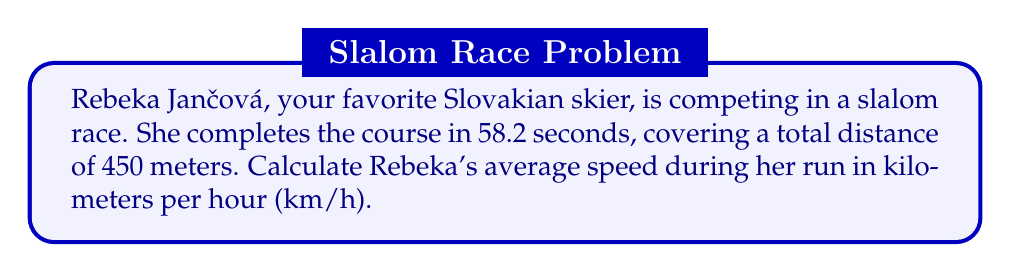Can you answer this question? To solve this problem, let's follow these steps:

1. Identify the given information:
   - Time taken: $t = 58.2$ seconds
   - Distance covered: $d = 450$ meters

2. Recall the formula for average speed:
   $$ \text{Average Speed} = \frac{\text{Total Distance}}{\text{Total Time}} $$

3. Calculate the average speed in meters per second:
   $$ \text{Average Speed} = \frac{450 \text{ m}}{58.2 \text{ s}} = 7.73 \text{ m/s} $$

4. Convert the speed from m/s to km/h:
   - There are 1000 meters in a kilometer and 3600 seconds in an hour
   $$ 7.73 \frac{\text{m}}{\text{s}} \times \frac{3600 \text{ s}}{1 \text{ h}} \times \frac{1 \text{ km}}{1000 \text{ m}} = 27.83 \frac{\text{km}}{\text{h}} $$

Therefore, Rebeka Jančová's average speed during her slalom run is approximately 27.83 km/h.
Answer: $27.83 \text{ km/h}$ 